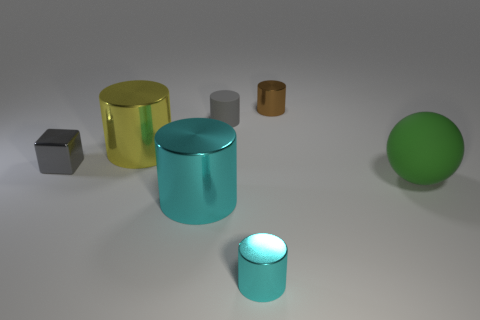Can you tell me the colors of the objects you see and how many of each are there? Certainly! In the image, I can discern objects of the following colors: one green sphere, one yellow cylinder, one cyan cylinder, one gray cube, one small brown cylinder, and one large cyan cylinder, which is a duplicate of the smaller one in color and material but differs in size. 